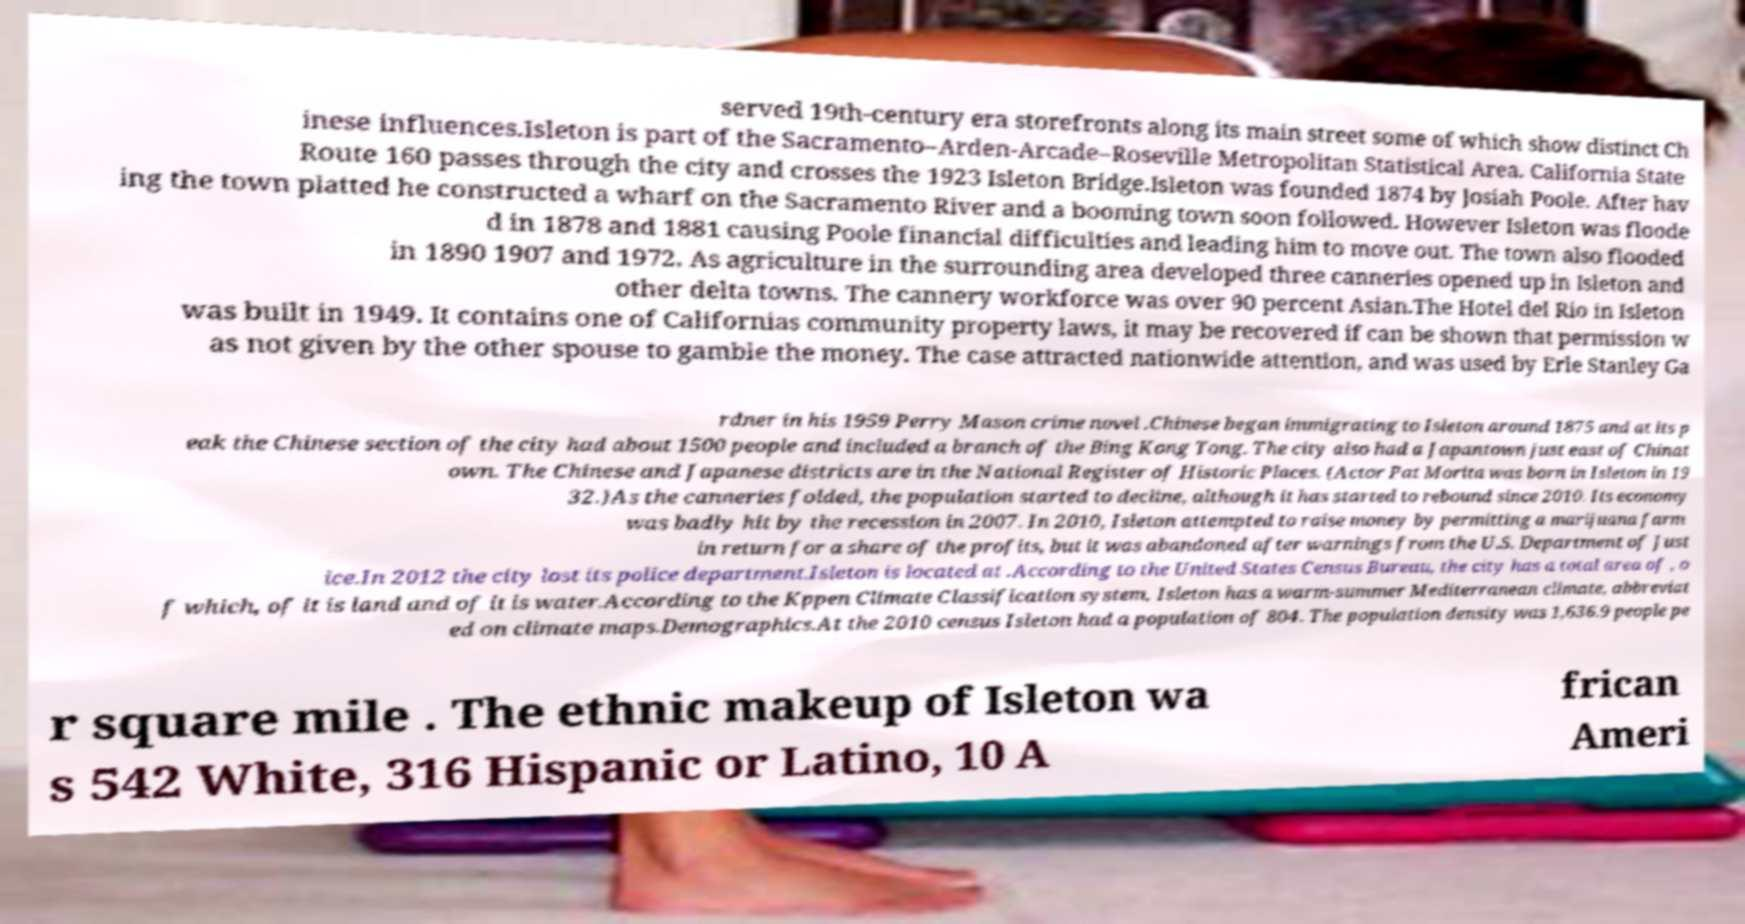Could you assist in decoding the text presented in this image and type it out clearly? served 19th-century era storefronts along its main street some of which show distinct Ch inese influences.Isleton is part of the Sacramento–Arden-Arcade–Roseville Metropolitan Statistical Area. California State Route 160 passes through the city and crosses the 1923 Isleton Bridge.Isleton was founded 1874 by Josiah Poole. After hav ing the town platted he constructed a wharf on the Sacramento River and a booming town soon followed. However Isleton was floode d in 1878 and 1881 causing Poole financial difficulties and leading him to move out. The town also flooded in 1890 1907 and 1972. As agriculture in the surrounding area developed three canneries opened up in Isleton and other delta towns. The cannery workforce was over 90 percent Asian.The Hotel del Rio in Isleton was built in 1949. It contains one of Californias community property laws, it may be recovered if can be shown that permission w as not given by the other spouse to gamble the money. The case attracted nationwide attention, and was used by Erle Stanley Ga rdner in his 1959 Perry Mason crime novel .Chinese began immigrating to Isleton around 1875 and at its p eak the Chinese section of the city had about 1500 people and included a branch of the Bing Kong Tong. The city also had a Japantown just east of Chinat own. The Chinese and Japanese districts are in the National Register of Historic Places. (Actor Pat Morita was born in Isleton in 19 32.)As the canneries folded, the population started to decline, although it has started to rebound since 2010. Its economy was badly hit by the recession in 2007. In 2010, Isleton attempted to raise money by permitting a marijuana farm in return for a share of the profits, but it was abandoned after warnings from the U.S. Department of Just ice.In 2012 the city lost its police department.Isleton is located at .According to the United States Census Bureau, the city has a total area of , o f which, of it is land and of it is water.According to the Kppen Climate Classification system, Isleton has a warm-summer Mediterranean climate, abbreviat ed on climate maps.Demographics.At the 2010 census Isleton had a population of 804. The population density was 1,636.9 people pe r square mile . The ethnic makeup of Isleton wa s 542 White, 316 Hispanic or Latino, 10 A frican Ameri 